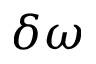<formula> <loc_0><loc_0><loc_500><loc_500>\delta \omega</formula> 